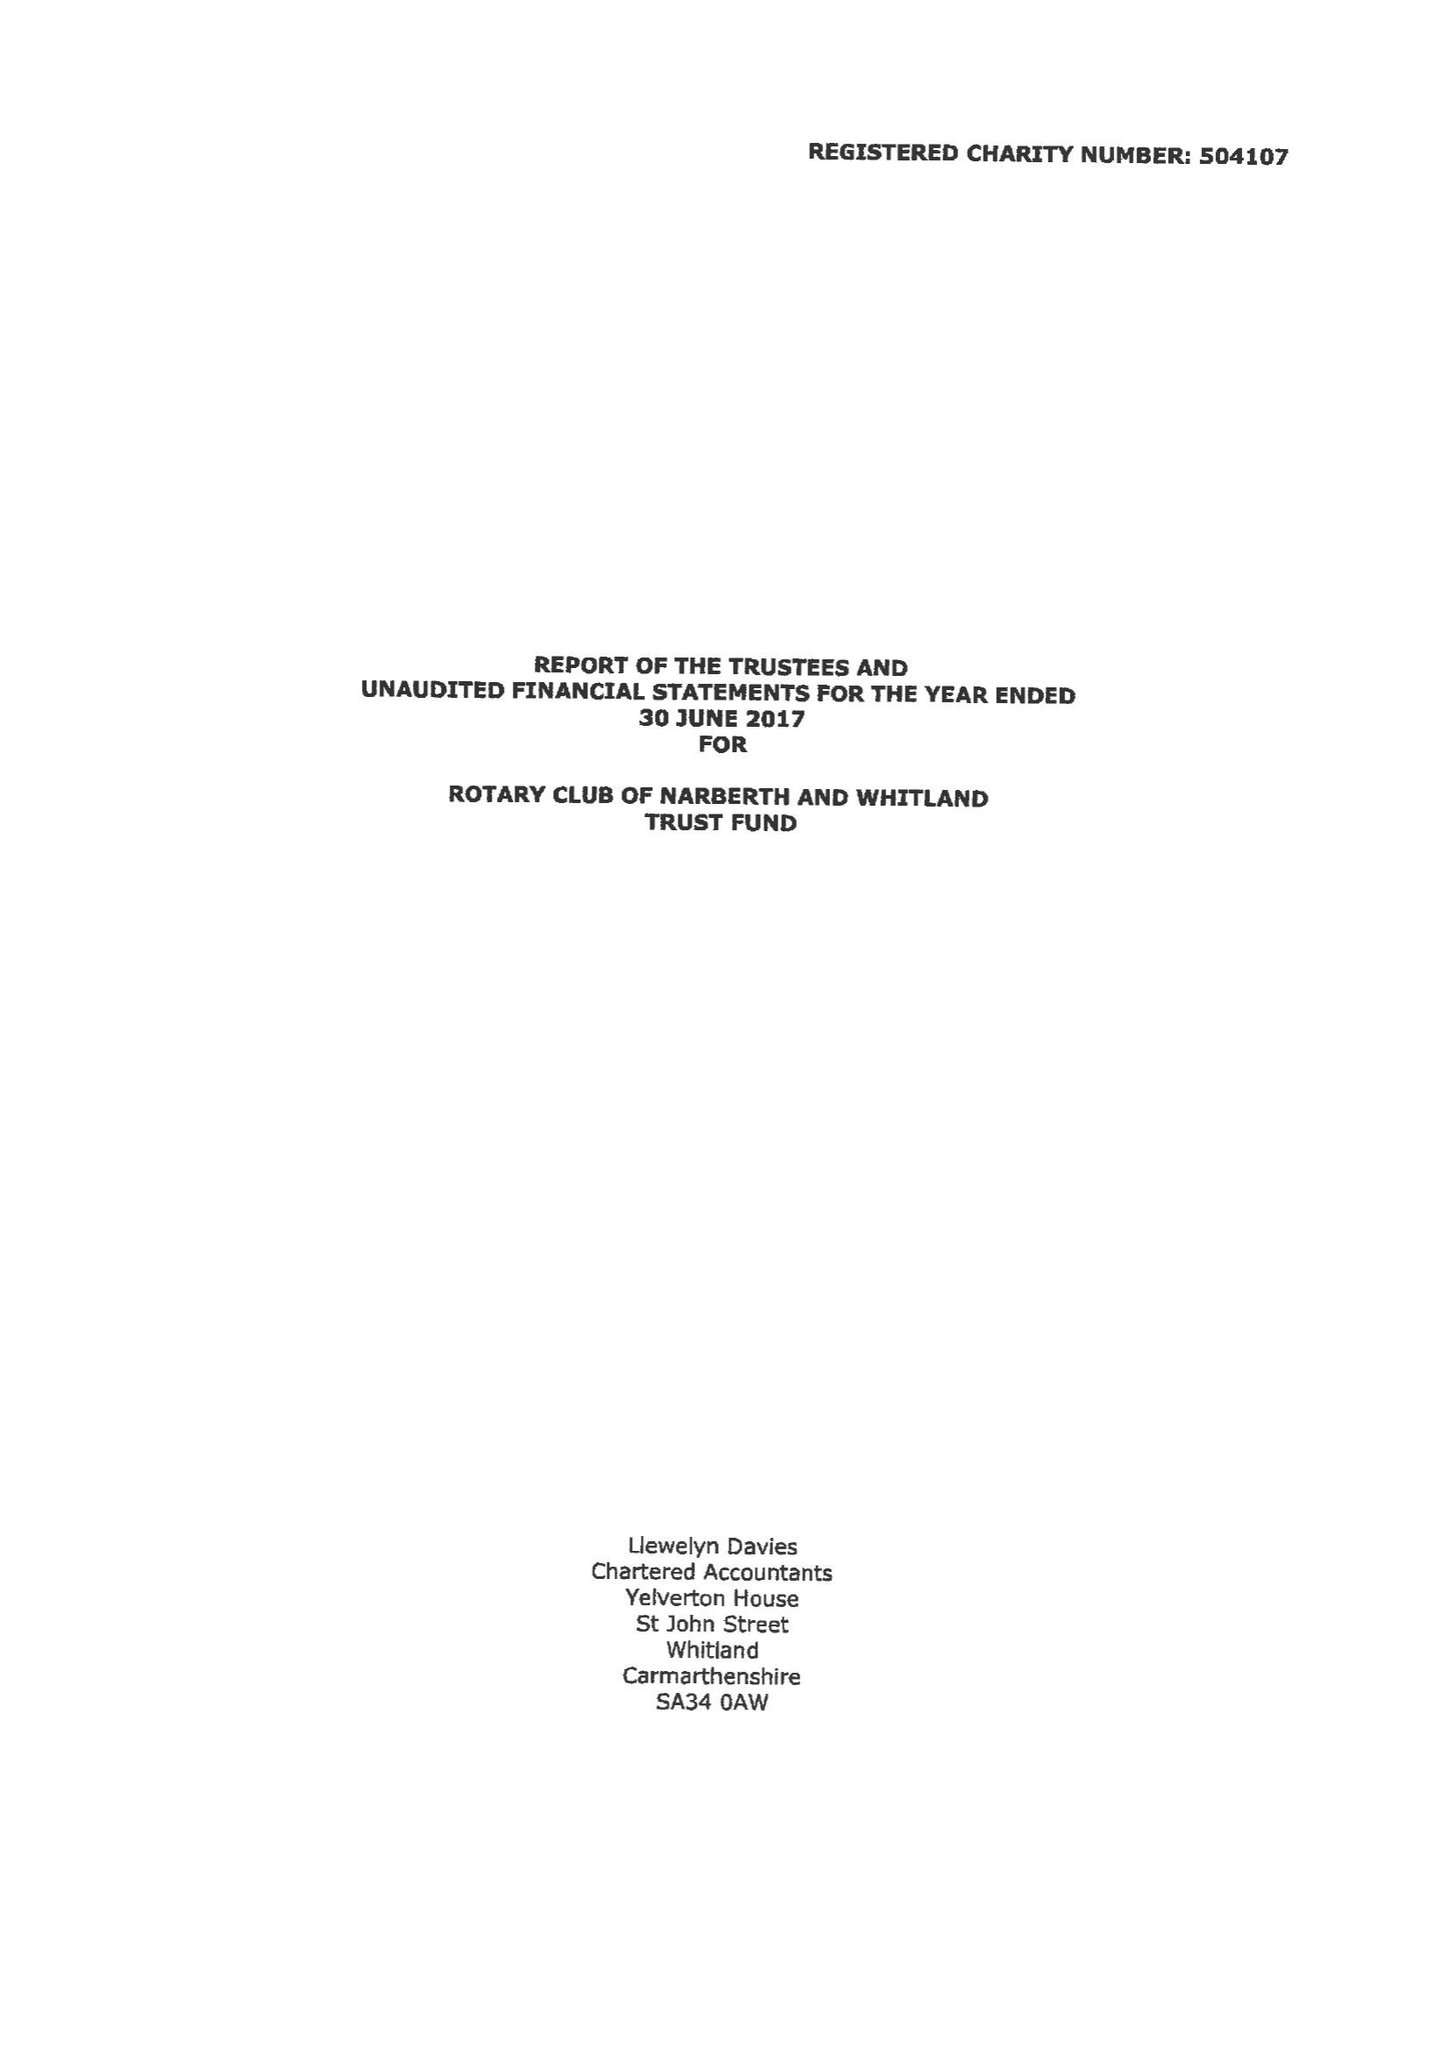What is the value for the income_annually_in_british_pounds?
Answer the question using a single word or phrase. 43436.00 